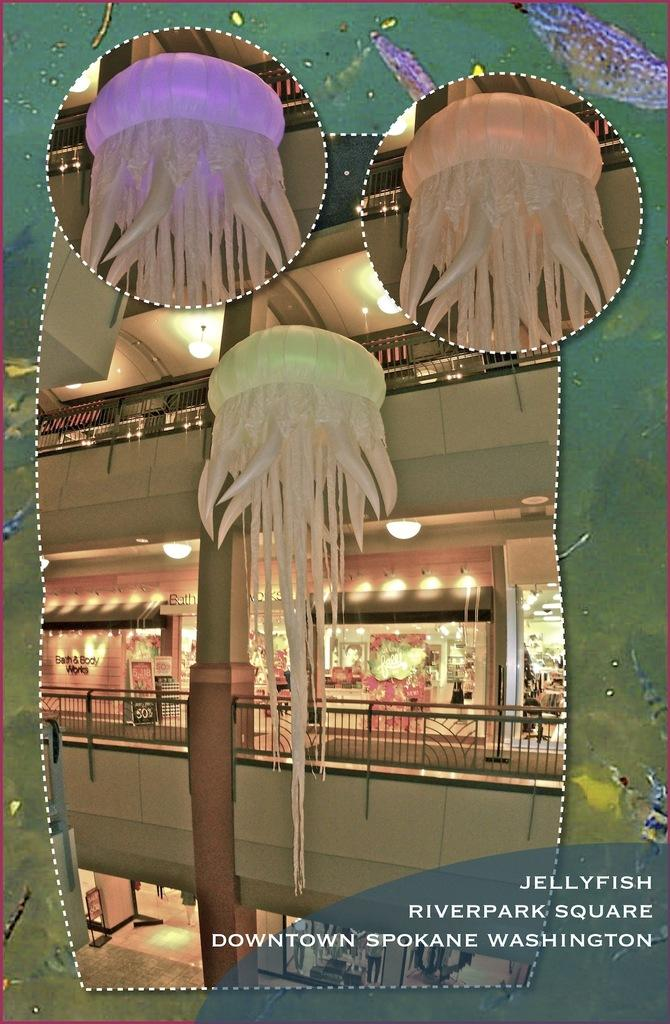Where is the location of the image? The image is inside a mall. What is featured within the frame in the image? There is a frame around a picture in the image. Can you describe the lighting in the image? There are lights visible in the image. What type of items can be seen in the image? Decoration items are present in the image. Is there any text in the image? Yes, there is edited text in the image. Can you see the ocean in the image? No, the ocean is not present in the image; it is inside a mall. 